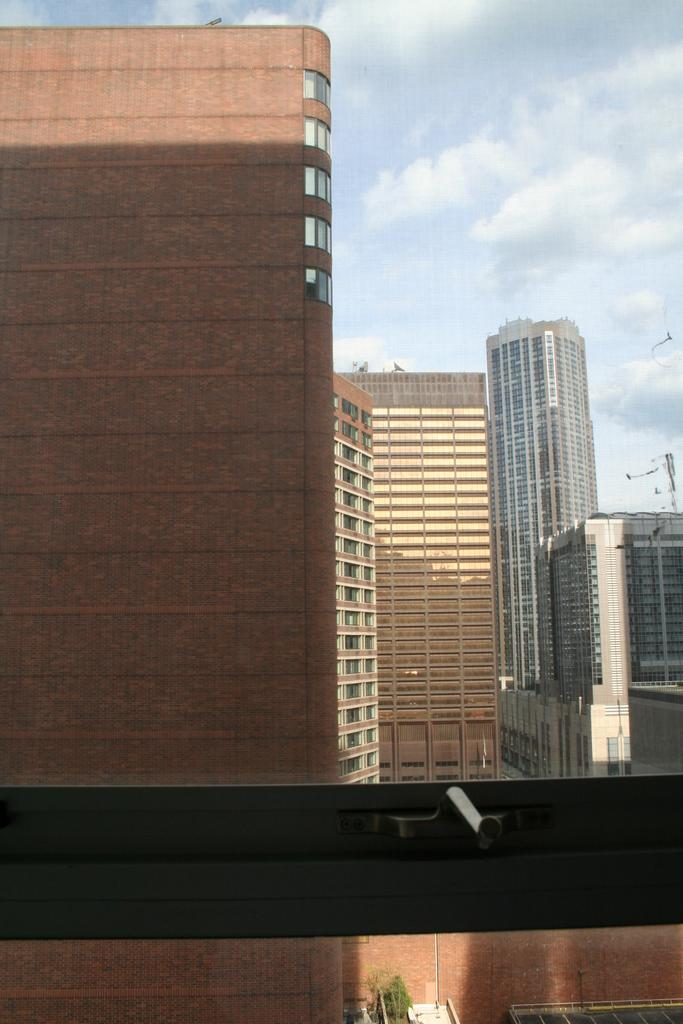What type of structures can be seen in the image? There are buildings in the image. What type of vegetation is present in the image? There is a plant in the image. What object can be seen standing upright in the image? There is a pole in the image. What can be seen on the side of the building in the image? There appears to be a window in the image. What is visible at the top of the image? The sky is visible at the top of the image. How many feet are visible in the image? There are no feet present in the image. What type of market can be seen in the image? There is no market present in the image. 